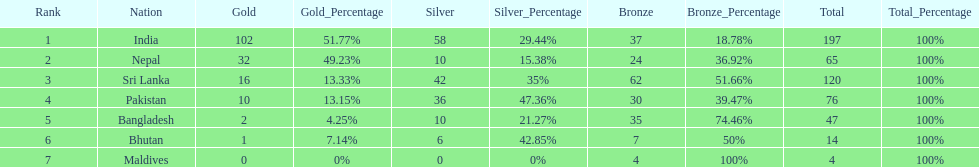What was the only nation to win less than 10 medals total? Maldives. 